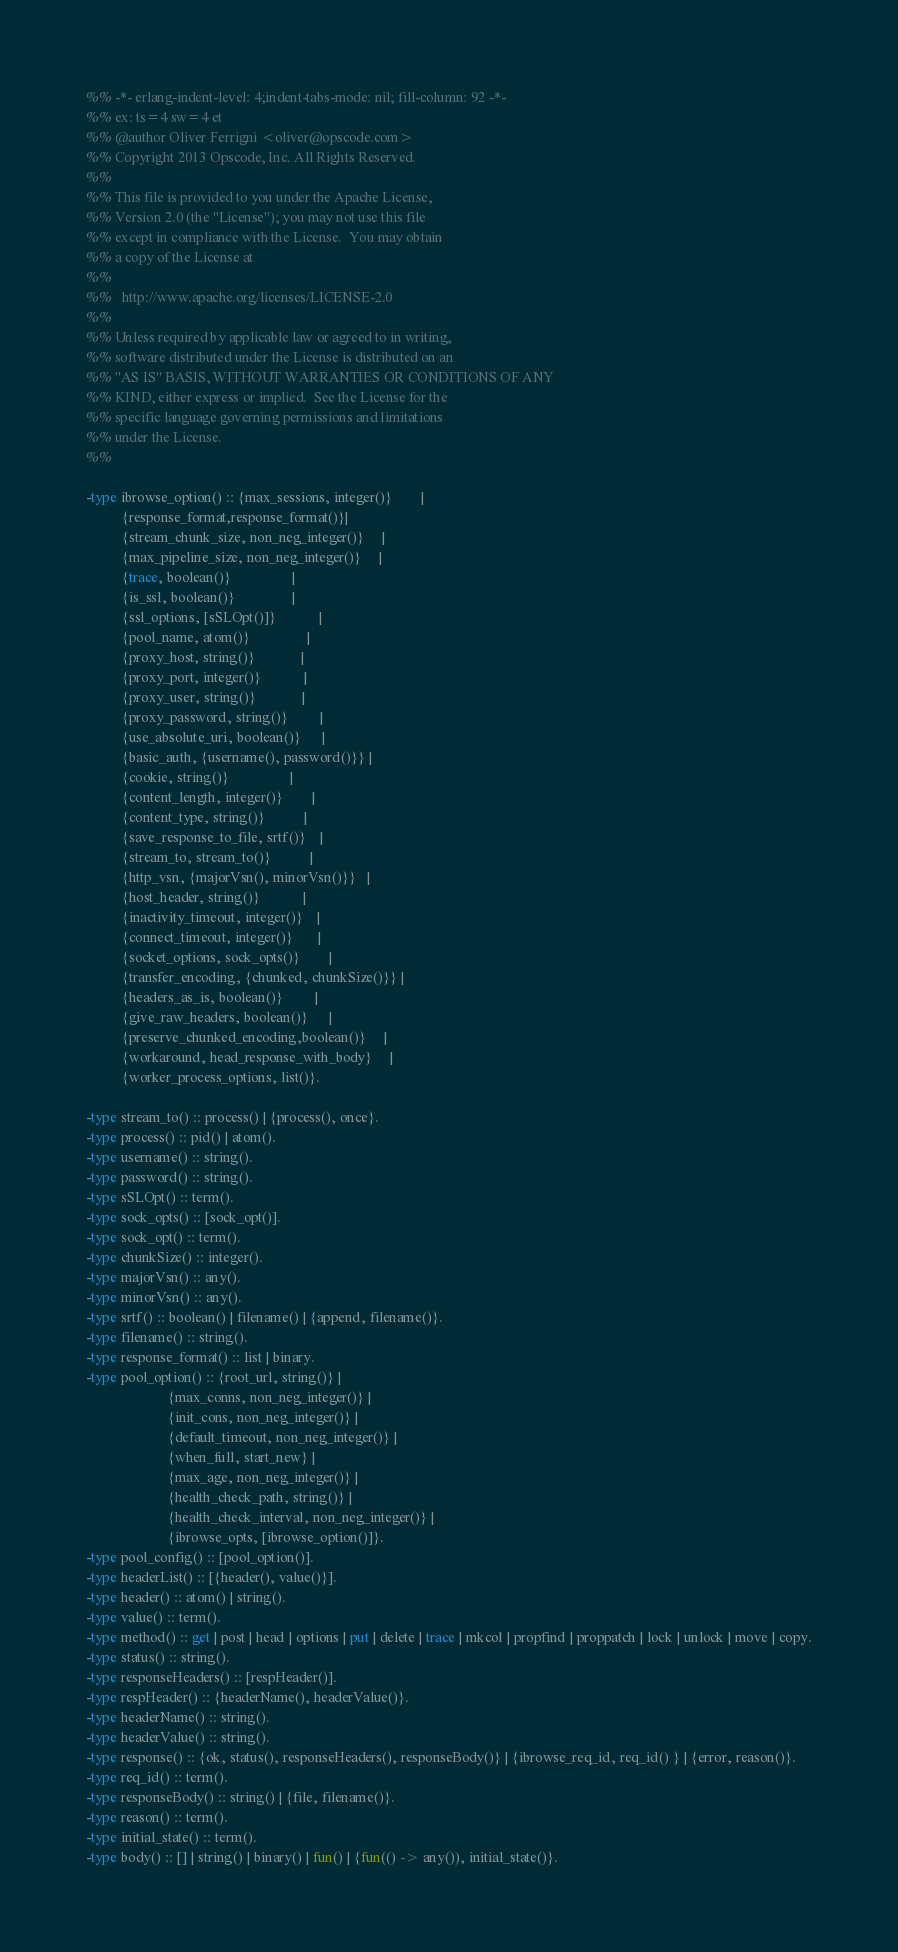Convert code to text. <code><loc_0><loc_0><loc_500><loc_500><_Erlang_>%% -*- erlang-indent-level: 4;indent-tabs-mode: nil; fill-column: 92 -*-
%% ex: ts=4 sw=4 et
%% @author Oliver Ferrigni <oliver@opscode.com>
%% Copyright 2013 Opscode, Inc. All Rights Reserved.
%%
%% This file is provided to you under the Apache License,
%% Version 2.0 (the "License"); you may not use this file
%% except in compliance with the License.  You may obtain
%% a copy of the License at
%%
%%   http://www.apache.org/licenses/LICENSE-2.0
%%
%% Unless required by applicable law or agreed to in writing,
%% software distributed under the License is distributed on an
%% "AS IS" BASIS, WITHOUT WARRANTIES OR CONDITIONS OF ANY
%% KIND, either express or implied.  See the License for the
%% specific language governing permissions and limitations
%% under the License.
%%

-type ibrowse_option() :: {max_sessions, integer()}        |
          {response_format,response_format()}|
          {stream_chunk_size, non_neg_integer()}     |
          {max_pipeline_size, non_neg_integer()}     |
          {trace, boolean()}                 | 
          {is_ssl, boolean()}                |
          {ssl_options, [sSLOpt()]}            |
          {pool_name, atom()}                |
          {proxy_host, string()}             |
          {proxy_port, integer()}            |
          {proxy_user, string()}             |
          {proxy_password, string()}         |
          {use_absolute_uri, boolean()}      |
          {basic_auth, {username(), password()}} |
          {cookie, string()}                 |
          {content_length, integer()}        |
          {content_type, string()}           |
          {save_response_to_file, srtf()}    |
          {stream_to, stream_to()}           |
          {http_vsn, {majorVsn(), minorVsn()}}   |
          {host_header, string()}            |
          {inactivity_timeout, integer()}    |
          {connect_timeout, integer()}       |
          {socket_options, sock_opts()}        |
          {transfer_encoding, {chunked, chunkSize()}} | 
          {headers_as_is, boolean()}         |
          {give_raw_headers, boolean()}      |
          {preserve_chunked_encoding,boolean()}     |
          {workaround, head_response_with_body}     |
          {worker_process_options, list()}.

-type stream_to() :: process() | {process(), once}.
-type process() :: pid() | atom().
-type username() :: string().
-type password() :: string().
-type sSLOpt() :: term().
-type sock_opts() :: [sock_opt()].
-type sock_opt() :: term().
-type chunkSize() :: integer().
-type majorVsn() :: any().
-type minorVsn() :: any().
-type srtf() :: boolean() | filename() | {append, filename()}.
-type filename() :: string().
-type response_format() :: list | binary.
-type pool_option() :: {root_url, string()} |
                       {max_conns, non_neg_integer()} | 
                       {init_cons, non_neg_integer()} |
                       {default_timeout, non_neg_integer()} |
                       {when_full, start_new} |
                       {max_age, non_neg_integer()} |
                       {health_check_path, string()} |
                       {health_check_interval, non_neg_integer()} |
                       {ibrowse_opts, [ibrowse_option()]}.
-type pool_config() :: [pool_option()].
-type headerList() :: [{header(), value()}].
-type header() :: atom() | string().
-type value() :: term().
-type method() :: get | post | head | options | put | delete | trace | mkcol | propfind | proppatch | lock | unlock | move | copy.
-type status() :: string().
-type responseHeaders() :: [respHeader()].
-type respHeader() :: {headerName(), headerValue()}.
-type headerName() :: string().
-type headerValue() :: string().
-type response() :: {ok, status(), responseHeaders(), responseBody()} | {ibrowse_req_id, req_id() } | {error, reason()}.
-type req_id() :: term().
-type responseBody() :: string() | {file, filename()}.
-type reason() :: term().
-type initial_state() :: term().
-type body() :: [] | string() | binary() | fun() | {fun(() -> any()), initial_state()}.
</code> 